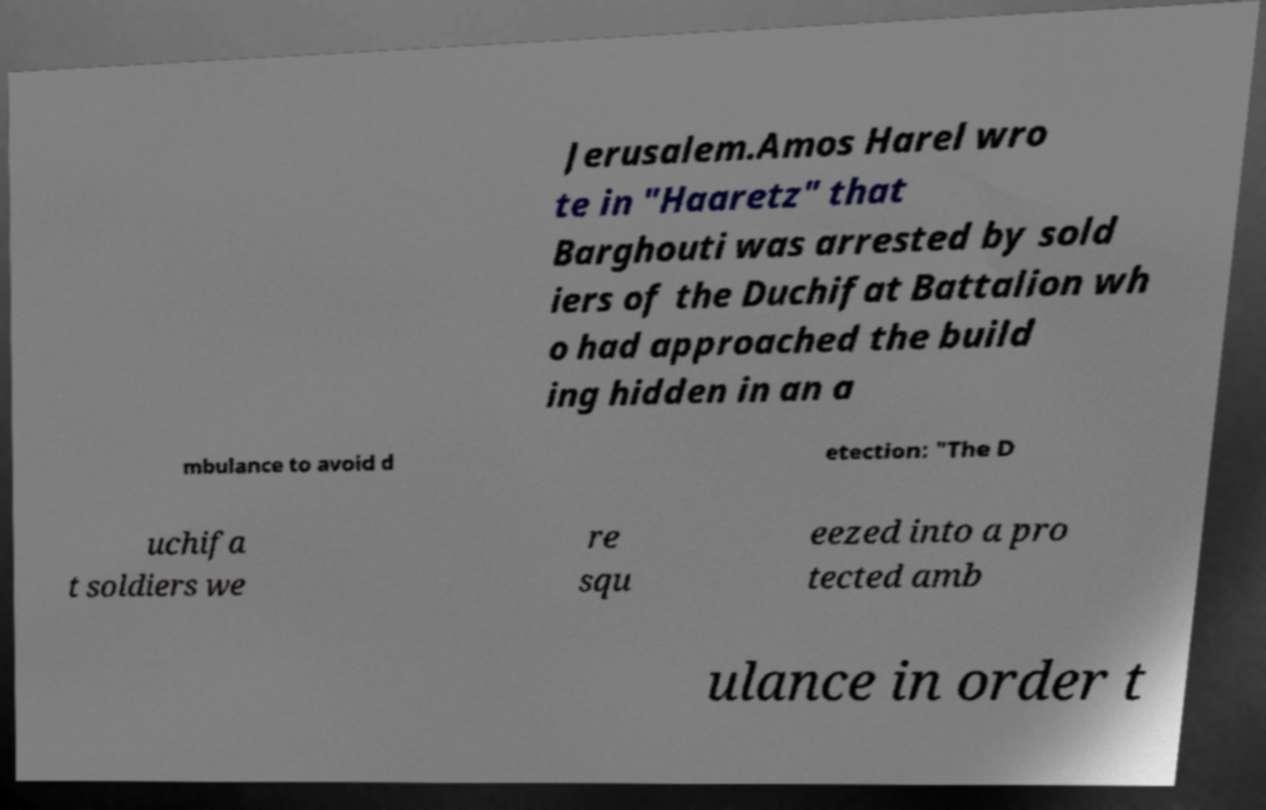Could you assist in decoding the text presented in this image and type it out clearly? Jerusalem.Amos Harel wro te in "Haaretz" that Barghouti was arrested by sold iers of the Duchifat Battalion wh o had approached the build ing hidden in an a mbulance to avoid d etection: "The D uchifa t soldiers we re squ eezed into a pro tected amb ulance in order t 